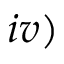Convert formula to latex. <formula><loc_0><loc_0><loc_500><loc_500>i v )</formula> 